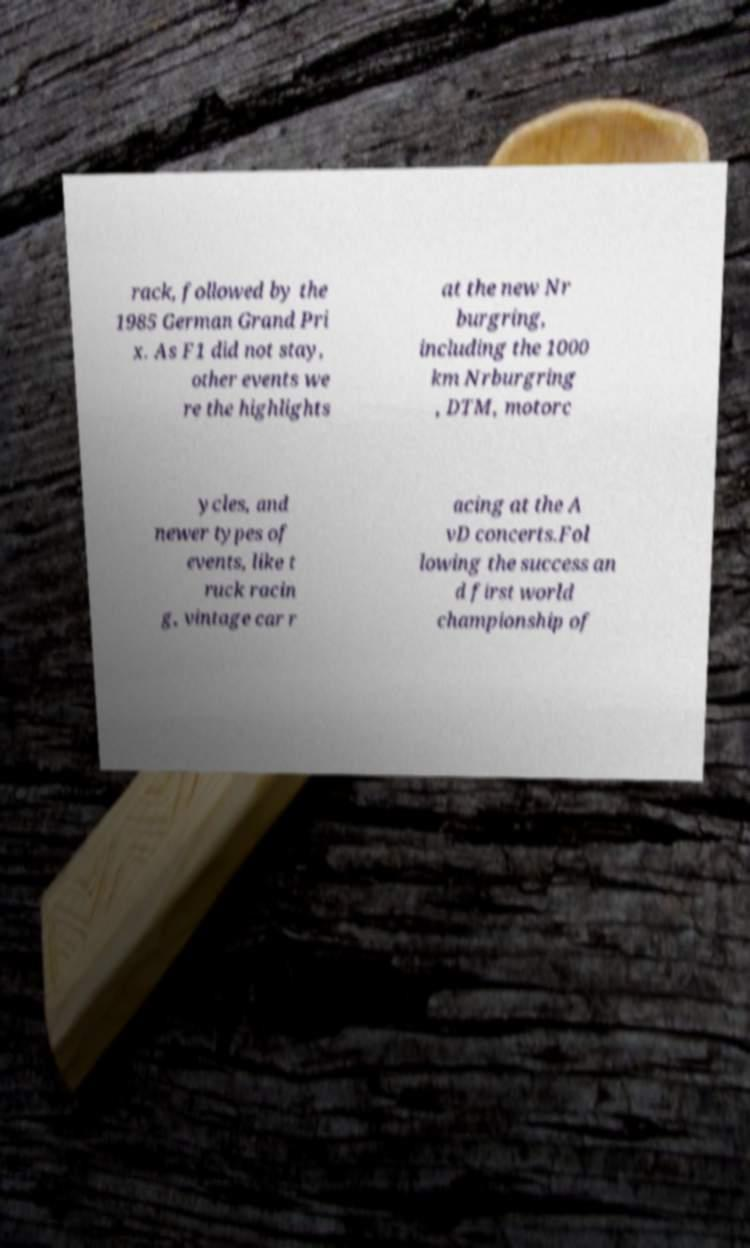What messages or text are displayed in this image? I need them in a readable, typed format. rack, followed by the 1985 German Grand Pri x. As F1 did not stay, other events we re the highlights at the new Nr burgring, including the 1000 km Nrburgring , DTM, motorc ycles, and newer types of events, like t ruck racin g, vintage car r acing at the A vD concerts.Fol lowing the success an d first world championship of 